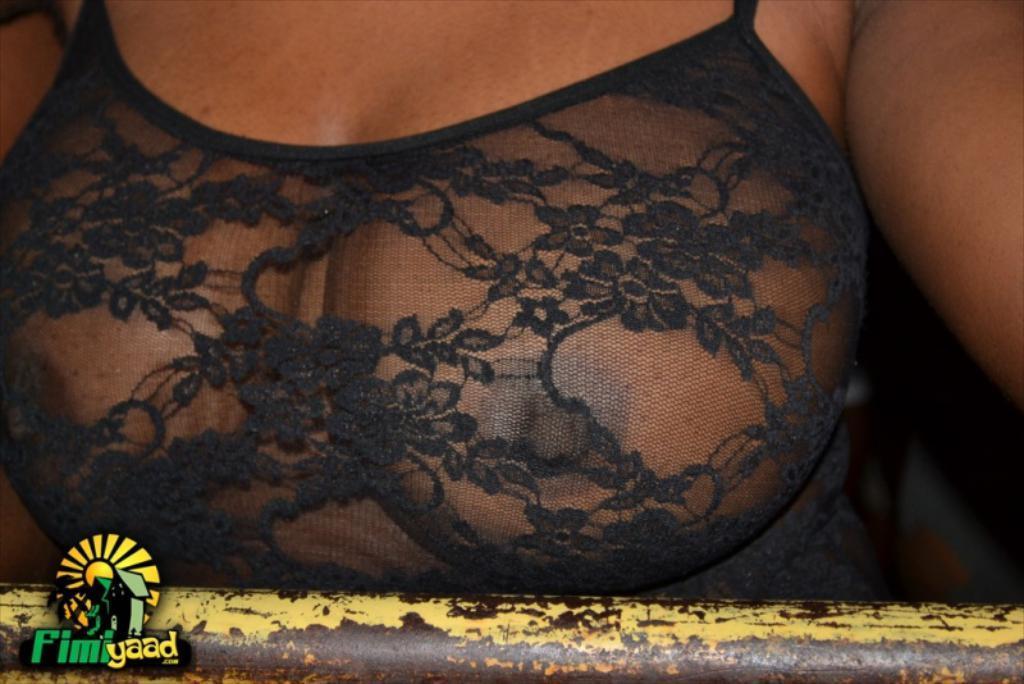Describe this image in one or two sentences. In this image I can see the breast of a woman. 